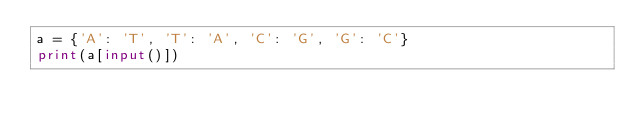<code> <loc_0><loc_0><loc_500><loc_500><_Python_>a = {'A': 'T', 'T': 'A', 'C': 'G', 'G': 'C'}
print(a[input()])</code> 